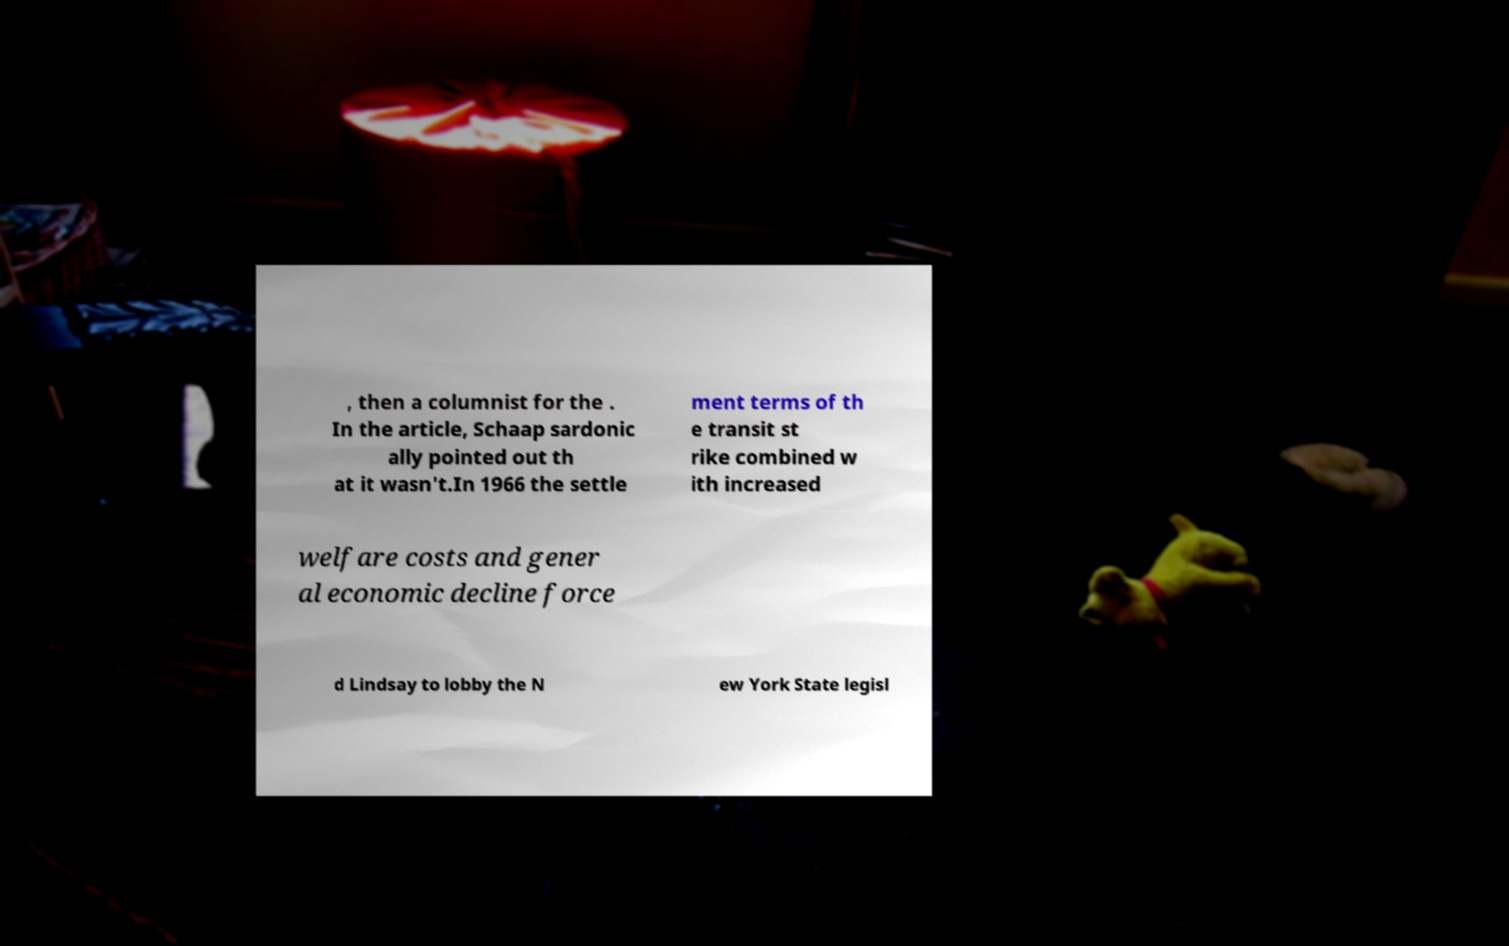Could you extract and type out the text from this image? , then a columnist for the . In the article, Schaap sardonic ally pointed out th at it wasn't.In 1966 the settle ment terms of th e transit st rike combined w ith increased welfare costs and gener al economic decline force d Lindsay to lobby the N ew York State legisl 